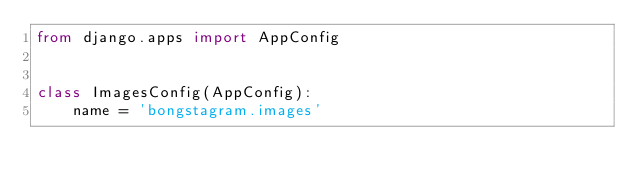<code> <loc_0><loc_0><loc_500><loc_500><_Python_>from django.apps import AppConfig


class ImagesConfig(AppConfig):
    name = 'bongstagram.images'
</code> 